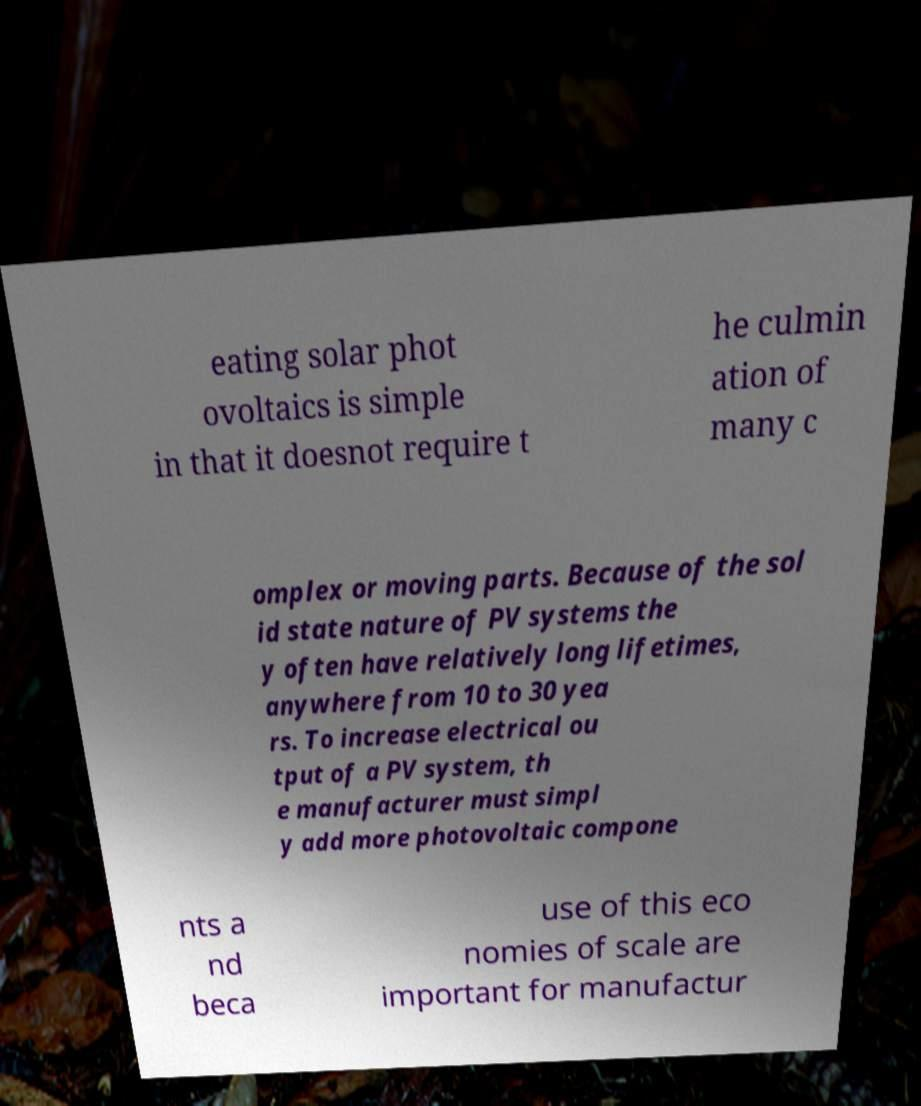Can you accurately transcribe the text from the provided image for me? eating solar phot ovoltaics is simple in that it doesnot require t he culmin ation of many c omplex or moving parts. Because of the sol id state nature of PV systems the y often have relatively long lifetimes, anywhere from 10 to 30 yea rs. To increase electrical ou tput of a PV system, th e manufacturer must simpl y add more photovoltaic compone nts a nd beca use of this eco nomies of scale are important for manufactur 